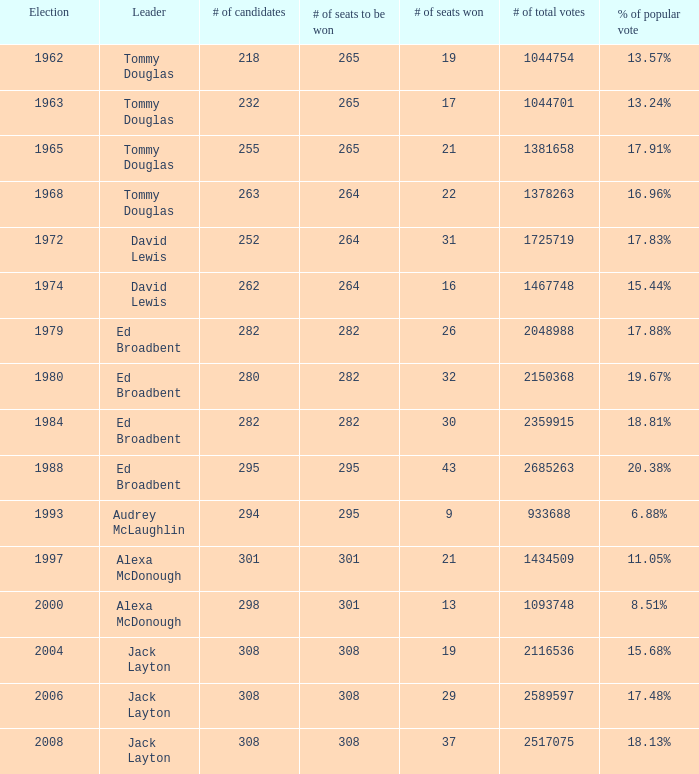88% proportion of the popular vote. 295.0. 